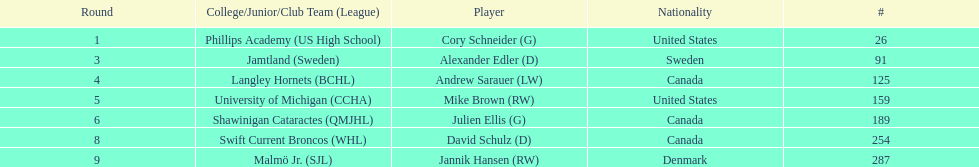Which player has canadian nationality and attended langley hornets? Andrew Sarauer (LW). 